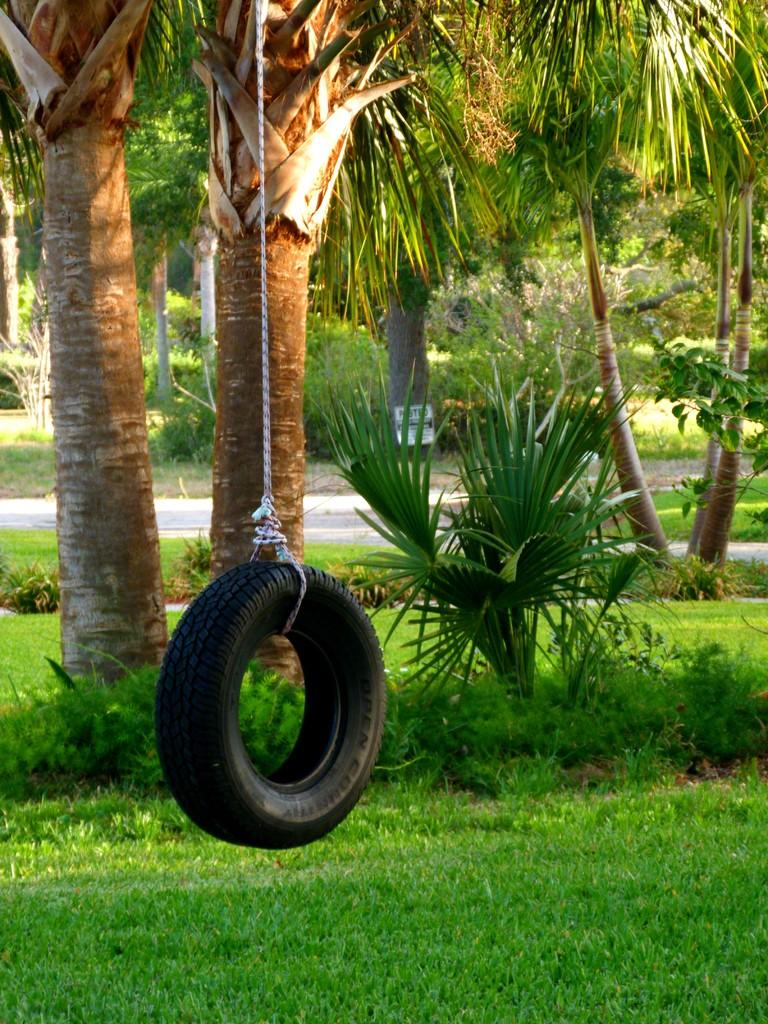What object is tied to a rope in the image? There is a tire tied to a rope in the image. What is the ground surface like in the image? The ground is covered with grass. What type of vegetation can be seen on the ground? There are plants on the ground. What can be seen in the background of the image? There are trees visible in the background of the image. What invention is being demonstrated in the image? There is no invention being demonstrated in the image; it simply shows a tire tied to a rope. What time of day is it in the image? The time of day cannot be determined from the image, as there are no specific clues or indicators present. 